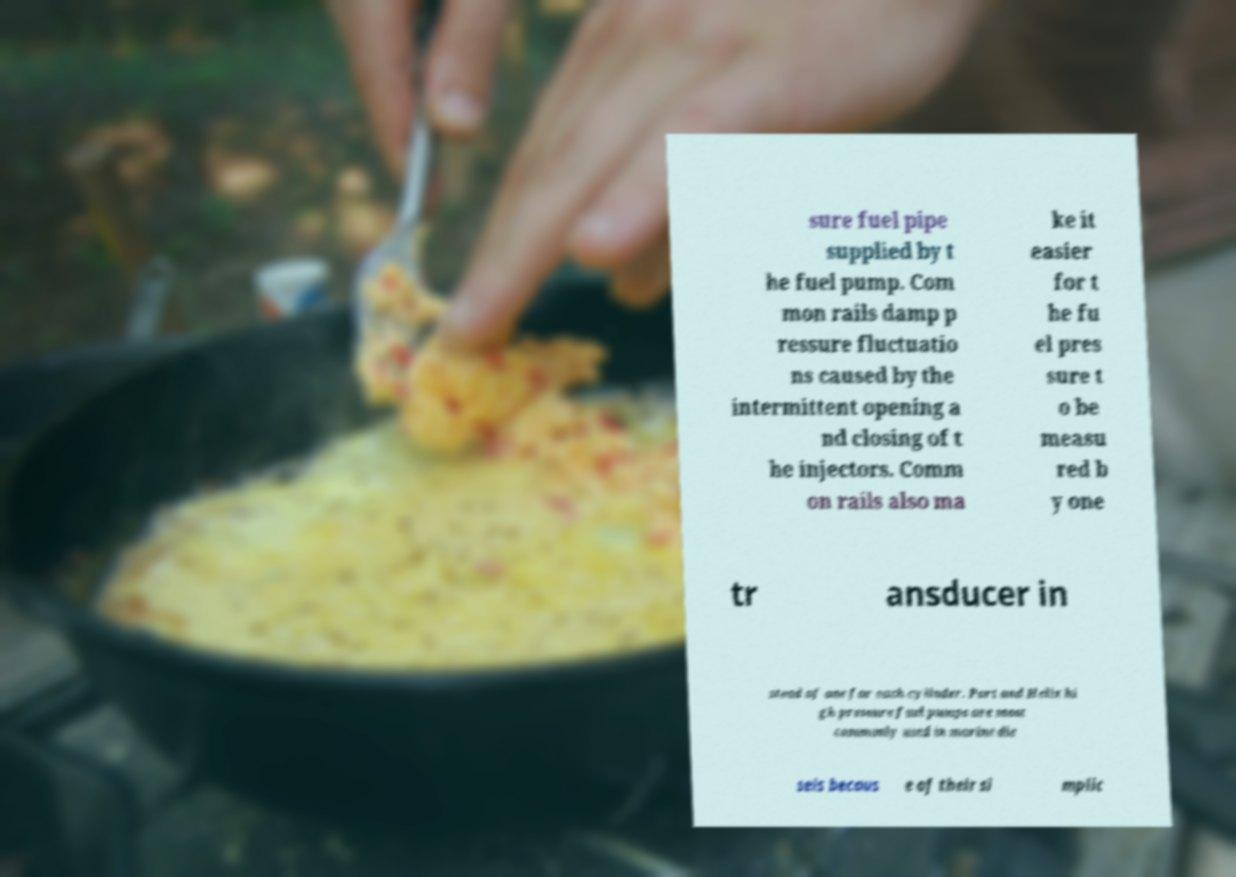Could you extract and type out the text from this image? sure fuel pipe supplied by t he fuel pump. Com mon rails damp p ressure fluctuatio ns caused by the intermittent opening a nd closing of t he injectors. Comm on rails also ma ke it easier for t he fu el pres sure t o be measu red b y one tr ansducer in stead of one for each cylinder. Port and Helix hi gh pressure fuel pumps are most commonly used in marine die sels becaus e of their si mplic 